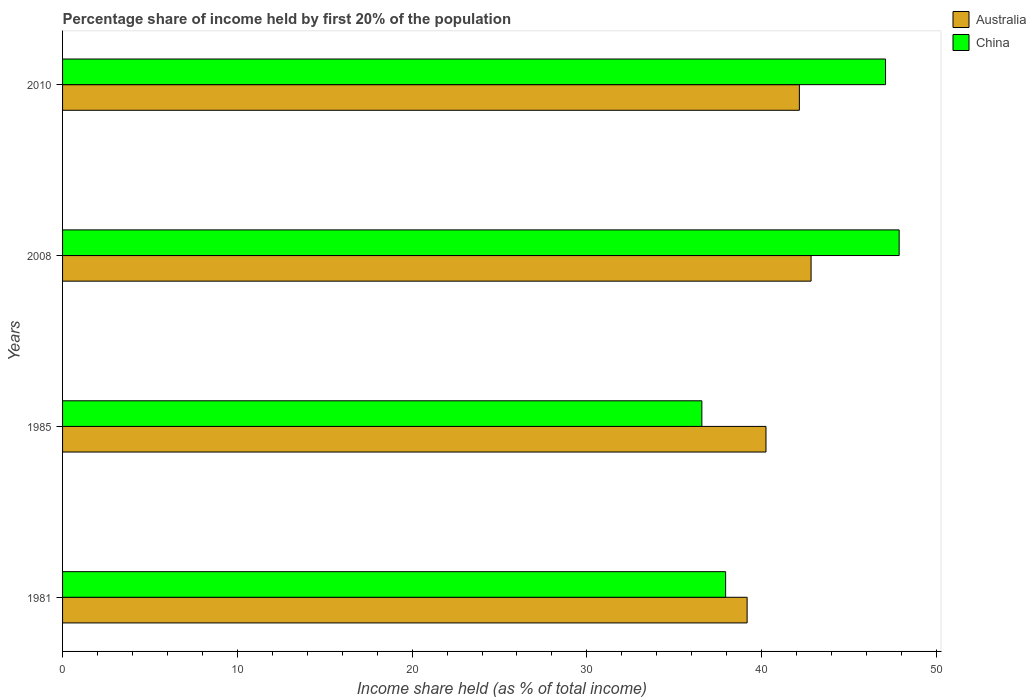How many bars are there on the 1st tick from the bottom?
Keep it short and to the point. 2. What is the share of income held by first 20% of the population in Australia in 1985?
Provide a succinct answer. 40.25. Across all years, what is the maximum share of income held by first 20% of the population in Australia?
Provide a short and direct response. 42.83. Across all years, what is the minimum share of income held by first 20% of the population in China?
Your response must be concise. 36.58. In which year was the share of income held by first 20% of the population in China maximum?
Offer a very short reply. 2008. In which year was the share of income held by first 20% of the population in Australia minimum?
Offer a terse response. 1981. What is the total share of income held by first 20% of the population in China in the graph?
Offer a very short reply. 169.48. What is the difference between the share of income held by first 20% of the population in Australia in 1981 and that in 1985?
Give a very brief answer. -1.08. What is the difference between the share of income held by first 20% of the population in Australia in 1981 and the share of income held by first 20% of the population in China in 1985?
Your response must be concise. 2.59. What is the average share of income held by first 20% of the population in Australia per year?
Keep it short and to the point. 41.1. In the year 1985, what is the difference between the share of income held by first 20% of the population in Australia and share of income held by first 20% of the population in China?
Provide a short and direct response. 3.67. What is the ratio of the share of income held by first 20% of the population in Australia in 1981 to that in 2010?
Ensure brevity in your answer.  0.93. What is the difference between the highest and the second highest share of income held by first 20% of the population in Australia?
Offer a terse response. 0.67. What is the difference between the highest and the lowest share of income held by first 20% of the population in Australia?
Provide a succinct answer. 3.66. In how many years, is the share of income held by first 20% of the population in China greater than the average share of income held by first 20% of the population in China taken over all years?
Give a very brief answer. 2. Is the sum of the share of income held by first 20% of the population in China in 1985 and 2010 greater than the maximum share of income held by first 20% of the population in Australia across all years?
Keep it short and to the point. Yes. What does the 2nd bar from the bottom in 1981 represents?
Offer a very short reply. China. How many bars are there?
Ensure brevity in your answer.  8. Are all the bars in the graph horizontal?
Provide a succinct answer. Yes. How many years are there in the graph?
Provide a succinct answer. 4. Are the values on the major ticks of X-axis written in scientific E-notation?
Keep it short and to the point. No. Does the graph contain any zero values?
Ensure brevity in your answer.  No. Does the graph contain grids?
Keep it short and to the point. No. Where does the legend appear in the graph?
Provide a succinct answer. Top right. What is the title of the graph?
Provide a short and direct response. Percentage share of income held by first 20% of the population. What is the label or title of the X-axis?
Make the answer very short. Income share held (as % of total income). What is the label or title of the Y-axis?
Offer a very short reply. Years. What is the Income share held (as % of total income) in Australia in 1981?
Make the answer very short. 39.17. What is the Income share held (as % of total income) of China in 1981?
Provide a short and direct response. 37.94. What is the Income share held (as % of total income) of Australia in 1985?
Make the answer very short. 40.25. What is the Income share held (as % of total income) in China in 1985?
Give a very brief answer. 36.58. What is the Income share held (as % of total income) in Australia in 2008?
Make the answer very short. 42.83. What is the Income share held (as % of total income) in China in 2008?
Offer a very short reply. 47.87. What is the Income share held (as % of total income) of Australia in 2010?
Your answer should be compact. 42.16. What is the Income share held (as % of total income) in China in 2010?
Keep it short and to the point. 47.09. Across all years, what is the maximum Income share held (as % of total income) of Australia?
Your response must be concise. 42.83. Across all years, what is the maximum Income share held (as % of total income) in China?
Keep it short and to the point. 47.87. Across all years, what is the minimum Income share held (as % of total income) in Australia?
Offer a terse response. 39.17. Across all years, what is the minimum Income share held (as % of total income) of China?
Make the answer very short. 36.58. What is the total Income share held (as % of total income) of Australia in the graph?
Your answer should be very brief. 164.41. What is the total Income share held (as % of total income) in China in the graph?
Provide a succinct answer. 169.48. What is the difference between the Income share held (as % of total income) in Australia in 1981 and that in 1985?
Your answer should be very brief. -1.08. What is the difference between the Income share held (as % of total income) in China in 1981 and that in 1985?
Your answer should be very brief. 1.36. What is the difference between the Income share held (as % of total income) in Australia in 1981 and that in 2008?
Your answer should be very brief. -3.66. What is the difference between the Income share held (as % of total income) of China in 1981 and that in 2008?
Keep it short and to the point. -9.93. What is the difference between the Income share held (as % of total income) in Australia in 1981 and that in 2010?
Make the answer very short. -2.99. What is the difference between the Income share held (as % of total income) in China in 1981 and that in 2010?
Your answer should be compact. -9.15. What is the difference between the Income share held (as % of total income) of Australia in 1985 and that in 2008?
Provide a succinct answer. -2.58. What is the difference between the Income share held (as % of total income) in China in 1985 and that in 2008?
Provide a short and direct response. -11.29. What is the difference between the Income share held (as % of total income) of Australia in 1985 and that in 2010?
Your answer should be very brief. -1.91. What is the difference between the Income share held (as % of total income) of China in 1985 and that in 2010?
Provide a short and direct response. -10.51. What is the difference between the Income share held (as % of total income) in Australia in 2008 and that in 2010?
Provide a short and direct response. 0.67. What is the difference between the Income share held (as % of total income) of China in 2008 and that in 2010?
Offer a very short reply. 0.78. What is the difference between the Income share held (as % of total income) in Australia in 1981 and the Income share held (as % of total income) in China in 1985?
Offer a very short reply. 2.59. What is the difference between the Income share held (as % of total income) in Australia in 1981 and the Income share held (as % of total income) in China in 2008?
Ensure brevity in your answer.  -8.7. What is the difference between the Income share held (as % of total income) in Australia in 1981 and the Income share held (as % of total income) in China in 2010?
Make the answer very short. -7.92. What is the difference between the Income share held (as % of total income) in Australia in 1985 and the Income share held (as % of total income) in China in 2008?
Offer a terse response. -7.62. What is the difference between the Income share held (as % of total income) in Australia in 1985 and the Income share held (as % of total income) in China in 2010?
Your answer should be compact. -6.84. What is the difference between the Income share held (as % of total income) of Australia in 2008 and the Income share held (as % of total income) of China in 2010?
Provide a succinct answer. -4.26. What is the average Income share held (as % of total income) of Australia per year?
Your response must be concise. 41.1. What is the average Income share held (as % of total income) of China per year?
Provide a short and direct response. 42.37. In the year 1981, what is the difference between the Income share held (as % of total income) in Australia and Income share held (as % of total income) in China?
Your response must be concise. 1.23. In the year 1985, what is the difference between the Income share held (as % of total income) in Australia and Income share held (as % of total income) in China?
Provide a succinct answer. 3.67. In the year 2008, what is the difference between the Income share held (as % of total income) of Australia and Income share held (as % of total income) of China?
Give a very brief answer. -5.04. In the year 2010, what is the difference between the Income share held (as % of total income) in Australia and Income share held (as % of total income) in China?
Provide a succinct answer. -4.93. What is the ratio of the Income share held (as % of total income) in Australia in 1981 to that in 1985?
Provide a short and direct response. 0.97. What is the ratio of the Income share held (as % of total income) of China in 1981 to that in 1985?
Keep it short and to the point. 1.04. What is the ratio of the Income share held (as % of total income) of Australia in 1981 to that in 2008?
Offer a terse response. 0.91. What is the ratio of the Income share held (as % of total income) in China in 1981 to that in 2008?
Your answer should be compact. 0.79. What is the ratio of the Income share held (as % of total income) in Australia in 1981 to that in 2010?
Your response must be concise. 0.93. What is the ratio of the Income share held (as % of total income) in China in 1981 to that in 2010?
Keep it short and to the point. 0.81. What is the ratio of the Income share held (as % of total income) of Australia in 1985 to that in 2008?
Your response must be concise. 0.94. What is the ratio of the Income share held (as % of total income) in China in 1985 to that in 2008?
Your answer should be very brief. 0.76. What is the ratio of the Income share held (as % of total income) in Australia in 1985 to that in 2010?
Provide a short and direct response. 0.95. What is the ratio of the Income share held (as % of total income) in China in 1985 to that in 2010?
Ensure brevity in your answer.  0.78. What is the ratio of the Income share held (as % of total income) in Australia in 2008 to that in 2010?
Give a very brief answer. 1.02. What is the ratio of the Income share held (as % of total income) of China in 2008 to that in 2010?
Provide a short and direct response. 1.02. What is the difference between the highest and the second highest Income share held (as % of total income) of Australia?
Your answer should be compact. 0.67. What is the difference between the highest and the second highest Income share held (as % of total income) in China?
Offer a terse response. 0.78. What is the difference between the highest and the lowest Income share held (as % of total income) in Australia?
Your answer should be compact. 3.66. What is the difference between the highest and the lowest Income share held (as % of total income) in China?
Provide a succinct answer. 11.29. 